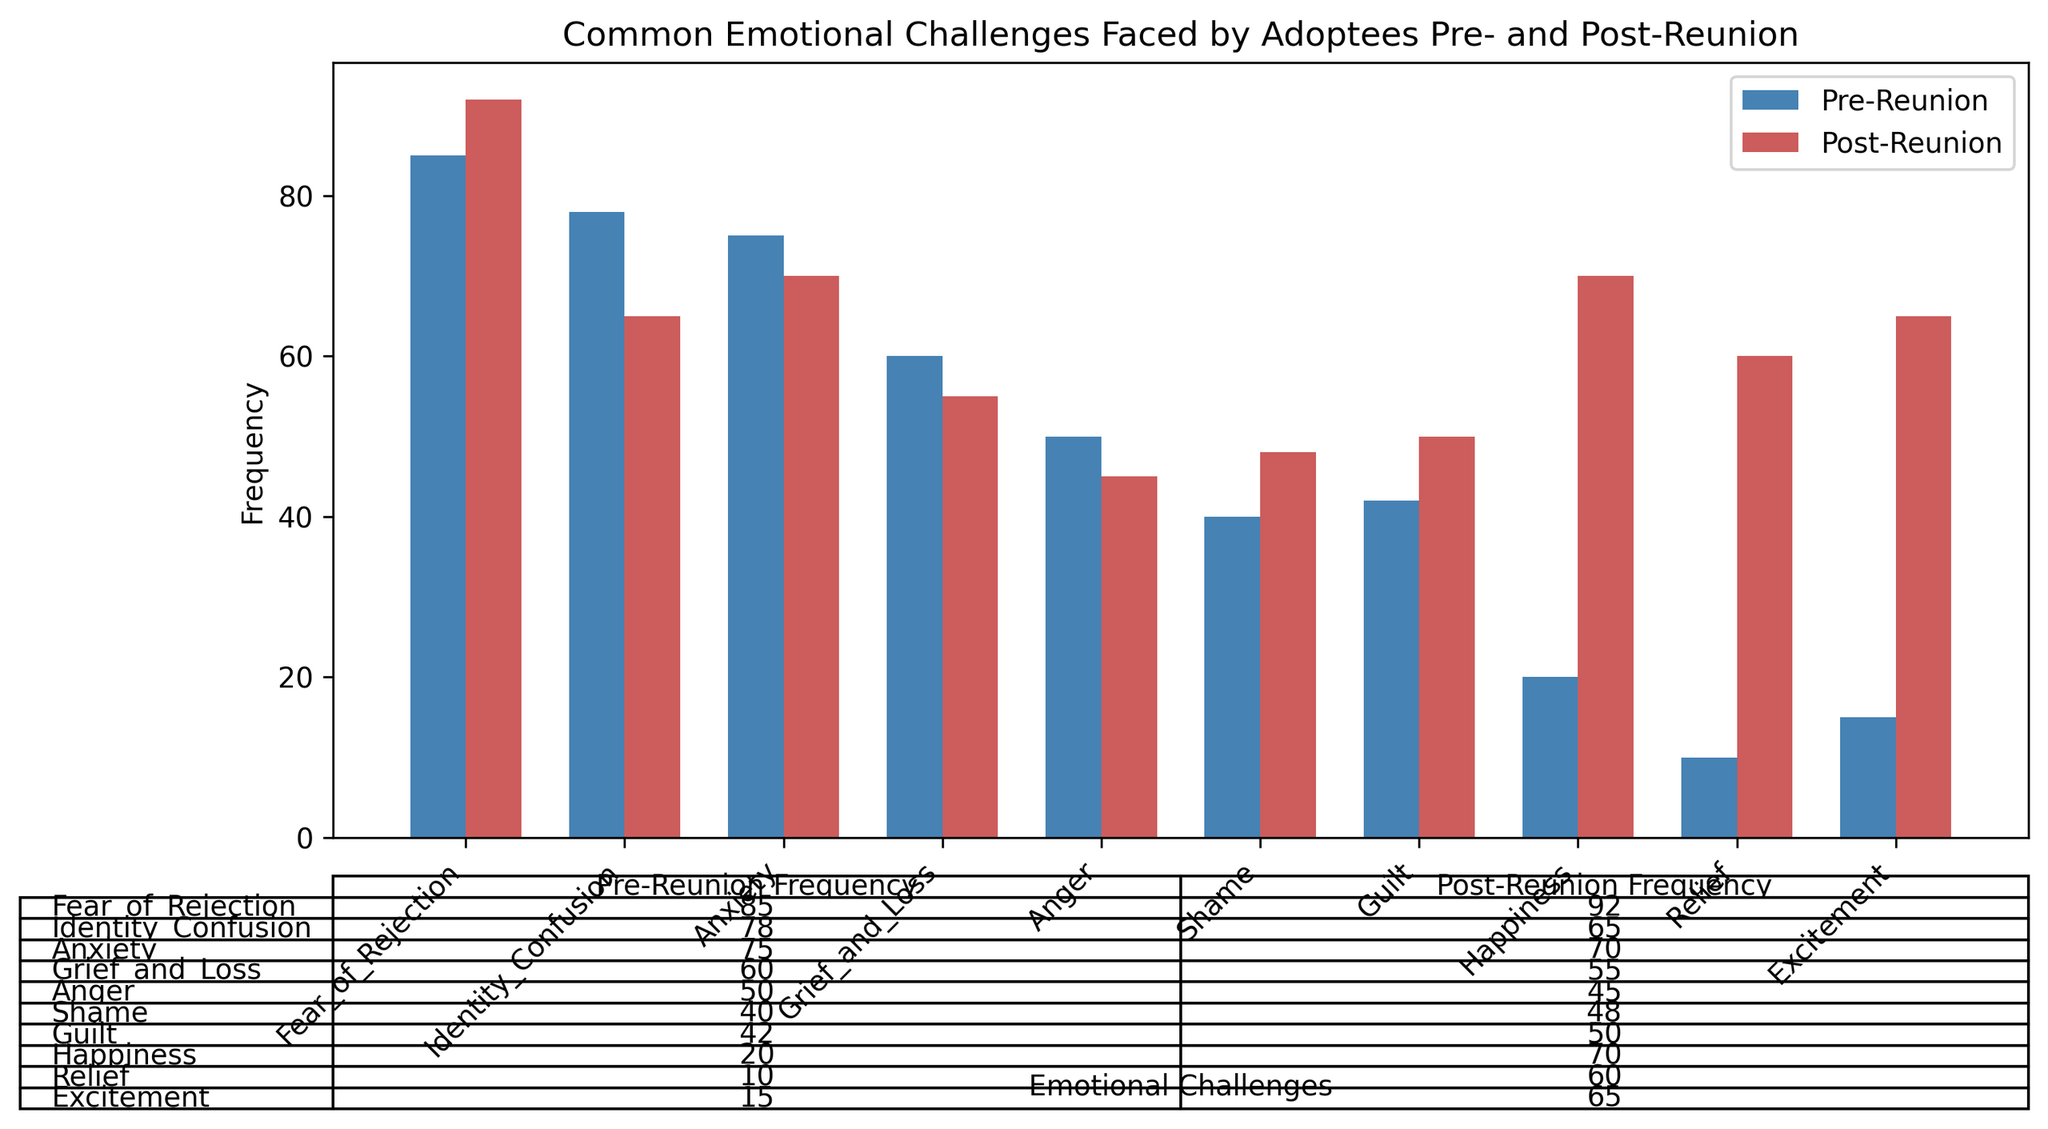Which emotional challenge shows the greatest increase in frequency post-reunion compared to pre-reunion? Compare the Pre-Reunion and Post-Reunion frequencies for each emotional challenge. The challenge with the largest positive difference indicates the greatest increase. "Happiness" shows the largest increase from 20 to 70.
Answer: Happiness Which emotional challenge shows the greatest decrease in frequency post-reunion compared to pre-reunion? Compare the Pre-Reunion and Post-Reunion frequencies for each emotional challenge. The challenge with the largest negative difference indicates the greatest decrease. "Identity Confusion" shows the largest decrease from 78 to 65.
Answer: Identity Confusion How many emotional challenges have a higher frequency pre-reunion than post-reunion? Count the number of emotional challenges where the Pre-Reunion frequency is greater than the Post-Reunion frequency. The challenges with higher Pre-Reunion frequencies are: "Identity Confusion", "Anxiety", "Grief and Loss", and "Anger" – totaling to 4.
Answer: 4 What is the average frequency of "Fear of Rejection" across both pre-reunion and post-reunion? Calculate the average by summing the Pre-Reunion and Post-Reunion frequencies for "Fear of Rejection" and then dividing by 2. (85 + 92) / 2 = 88.5
Answer: 88.5 Which emotional challenges have a Post-Reunion frequency of 70? Identify the emotional challenges that show a Post-Reunion frequency of 70. Both "Anxiety" and "Happiness" have a Post-Reunion frequency of 70.
Answer: Anxiety, Happiness What is the sum of post-reunion frequencies for "Shame", "Guilt", and "Relief"? Add the Post-Reunion frequencies of "Shame" (48), "Guilt" (50), and "Relief" (60) together. 48 + 50 + 60 = 158
Answer: 158 Which set of bars is colored in 'steelblue'? Identify the color associated with 'steelblue' indicated in the chart. The 'Pre-Reunion' frequency bars are colored in 'steelblue'.
Answer: Pre-Reunion Among "Fear of Rejection", "Identity Confusion", and "Anxiety", which one has the highest frequency pre-reunion? Compare the Pre-Reunion frequencies for "Fear of Rejection" (85), "Identity Confusion" (78), and "Anxiety" (75). "Fear of Rejection" has the highest frequency pre-reunion.
Answer: Fear of Rejection Which emotional challenge shows the same frequency in both pre-reunion and post-reunion periods? Compare the Pre-Reunion and Post-Reunion frequencies for each emotional challenge and find any that match. None of the challenges show equal frequency in both periods.
Answer: None 